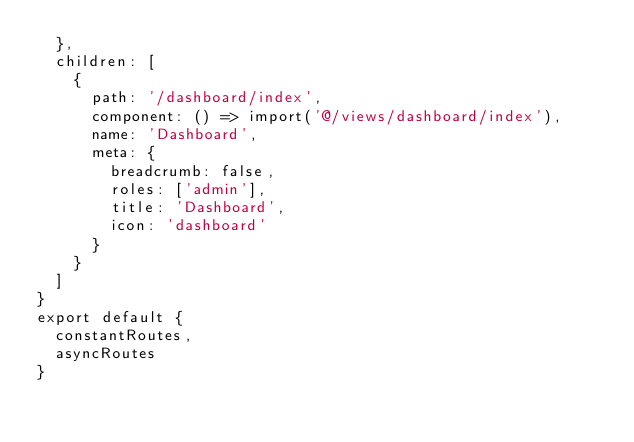<code> <loc_0><loc_0><loc_500><loc_500><_JavaScript_>  },
  children: [
    {
      path: '/dashboard/index',
      component: () => import('@/views/dashboard/index'),
      name: 'Dashboard',
      meta: {
        breadcrumb: false,
        roles: ['admin'],
        title: 'Dashboard',
        icon: 'dashboard'
      }
    }
  ]
}
export default {
  constantRoutes,
  asyncRoutes
}

</code> 